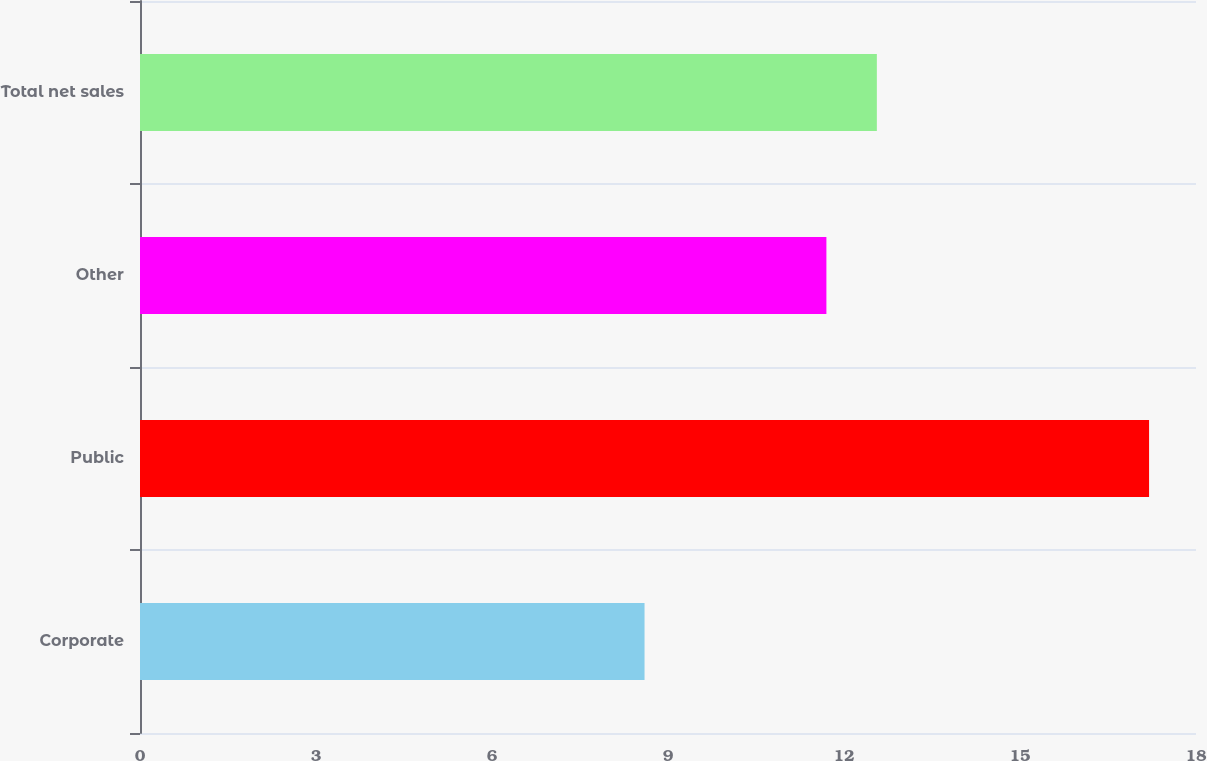Convert chart. <chart><loc_0><loc_0><loc_500><loc_500><bar_chart><fcel>Corporate<fcel>Public<fcel>Other<fcel>Total net sales<nl><fcel>8.6<fcel>17.2<fcel>11.7<fcel>12.56<nl></chart> 